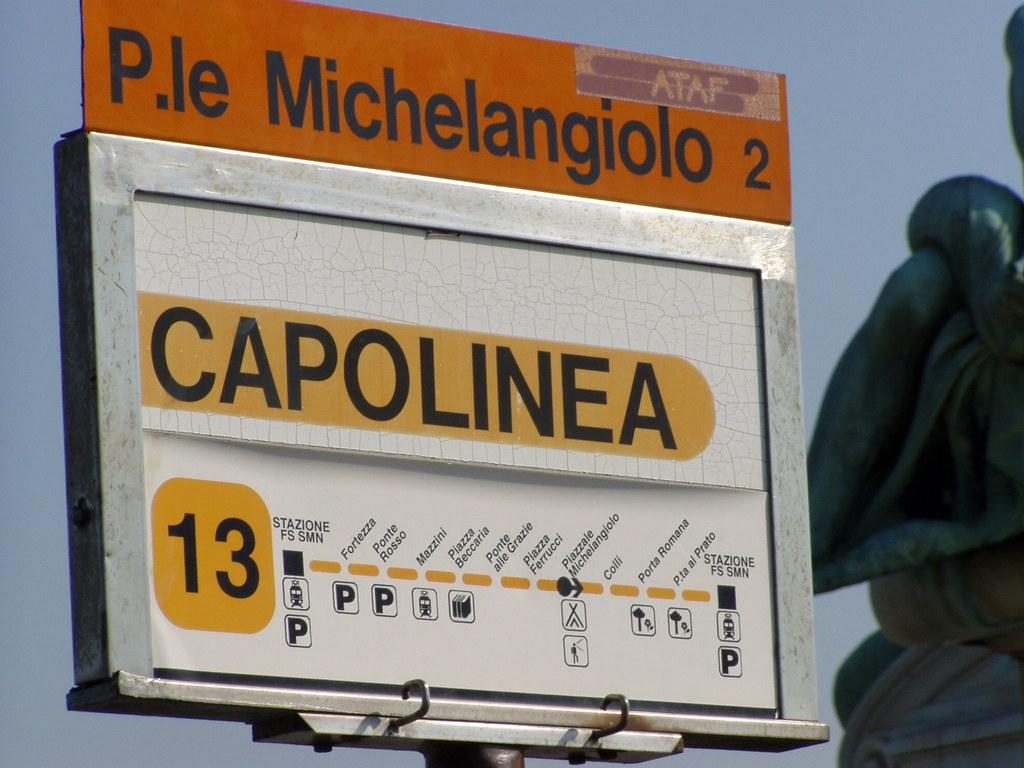<image>
Summarize the visual content of the image. A sign that states P.le Michelangiolo 2 and Capolinea. 